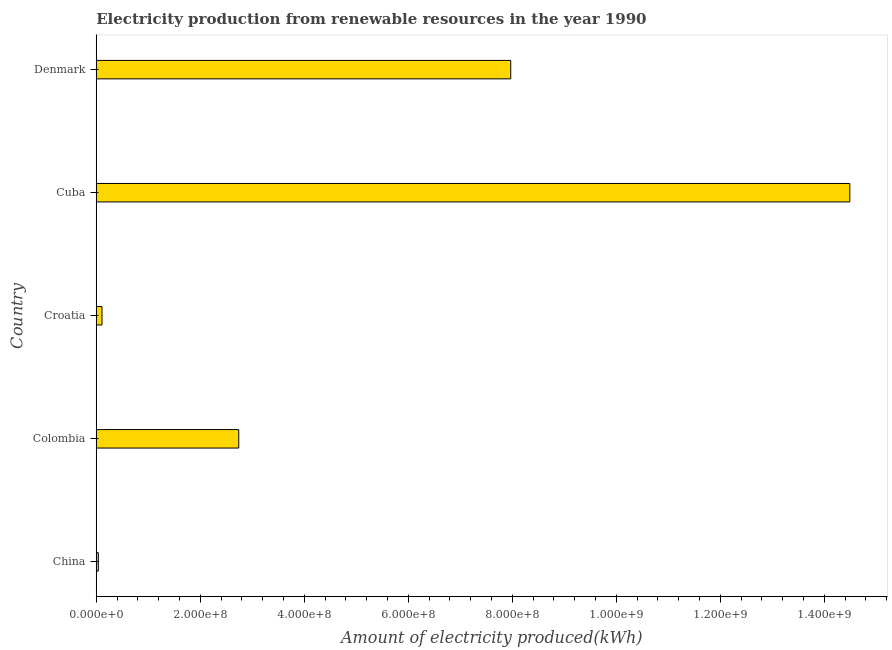What is the title of the graph?
Provide a succinct answer. Electricity production from renewable resources in the year 1990. What is the label or title of the X-axis?
Your response must be concise. Amount of electricity produced(kWh). What is the label or title of the Y-axis?
Your answer should be very brief. Country. What is the amount of electricity produced in Colombia?
Provide a succinct answer. 2.74e+08. Across all countries, what is the maximum amount of electricity produced?
Your answer should be compact. 1.45e+09. Across all countries, what is the minimum amount of electricity produced?
Your answer should be very brief. 4.00e+06. In which country was the amount of electricity produced maximum?
Offer a terse response. Cuba. What is the sum of the amount of electricity produced?
Provide a short and direct response. 2.54e+09. What is the difference between the amount of electricity produced in Croatia and Denmark?
Ensure brevity in your answer.  -7.86e+08. What is the average amount of electricity produced per country?
Ensure brevity in your answer.  5.07e+08. What is the median amount of electricity produced?
Give a very brief answer. 2.74e+08. What is the ratio of the amount of electricity produced in China to that in Denmark?
Give a very brief answer. 0.01. Is the difference between the amount of electricity produced in China and Cuba greater than the difference between any two countries?
Provide a succinct answer. Yes. What is the difference between the highest and the second highest amount of electricity produced?
Your answer should be compact. 6.52e+08. Is the sum of the amount of electricity produced in China and Croatia greater than the maximum amount of electricity produced across all countries?
Offer a very short reply. No. What is the difference between the highest and the lowest amount of electricity produced?
Your answer should be very brief. 1.44e+09. Are all the bars in the graph horizontal?
Give a very brief answer. Yes. Are the values on the major ticks of X-axis written in scientific E-notation?
Give a very brief answer. Yes. What is the Amount of electricity produced(kWh) of Colombia?
Make the answer very short. 2.74e+08. What is the Amount of electricity produced(kWh) of Croatia?
Offer a terse response. 1.10e+07. What is the Amount of electricity produced(kWh) in Cuba?
Offer a terse response. 1.45e+09. What is the Amount of electricity produced(kWh) of Denmark?
Make the answer very short. 7.97e+08. What is the difference between the Amount of electricity produced(kWh) in China and Colombia?
Ensure brevity in your answer.  -2.70e+08. What is the difference between the Amount of electricity produced(kWh) in China and Croatia?
Your response must be concise. -7.00e+06. What is the difference between the Amount of electricity produced(kWh) in China and Cuba?
Provide a succinct answer. -1.44e+09. What is the difference between the Amount of electricity produced(kWh) in China and Denmark?
Your answer should be compact. -7.93e+08. What is the difference between the Amount of electricity produced(kWh) in Colombia and Croatia?
Provide a succinct answer. 2.63e+08. What is the difference between the Amount of electricity produced(kWh) in Colombia and Cuba?
Your answer should be compact. -1.18e+09. What is the difference between the Amount of electricity produced(kWh) in Colombia and Denmark?
Make the answer very short. -5.23e+08. What is the difference between the Amount of electricity produced(kWh) in Croatia and Cuba?
Provide a succinct answer. -1.44e+09. What is the difference between the Amount of electricity produced(kWh) in Croatia and Denmark?
Your answer should be very brief. -7.86e+08. What is the difference between the Amount of electricity produced(kWh) in Cuba and Denmark?
Provide a succinct answer. 6.52e+08. What is the ratio of the Amount of electricity produced(kWh) in China to that in Colombia?
Your answer should be compact. 0.01. What is the ratio of the Amount of electricity produced(kWh) in China to that in Croatia?
Provide a succinct answer. 0.36. What is the ratio of the Amount of electricity produced(kWh) in China to that in Cuba?
Offer a very short reply. 0. What is the ratio of the Amount of electricity produced(kWh) in China to that in Denmark?
Your answer should be very brief. 0.01. What is the ratio of the Amount of electricity produced(kWh) in Colombia to that in Croatia?
Give a very brief answer. 24.91. What is the ratio of the Amount of electricity produced(kWh) in Colombia to that in Cuba?
Your response must be concise. 0.19. What is the ratio of the Amount of electricity produced(kWh) in Colombia to that in Denmark?
Provide a short and direct response. 0.34. What is the ratio of the Amount of electricity produced(kWh) in Croatia to that in Cuba?
Your answer should be compact. 0.01. What is the ratio of the Amount of electricity produced(kWh) in Croatia to that in Denmark?
Provide a short and direct response. 0.01. What is the ratio of the Amount of electricity produced(kWh) in Cuba to that in Denmark?
Your answer should be very brief. 1.82. 